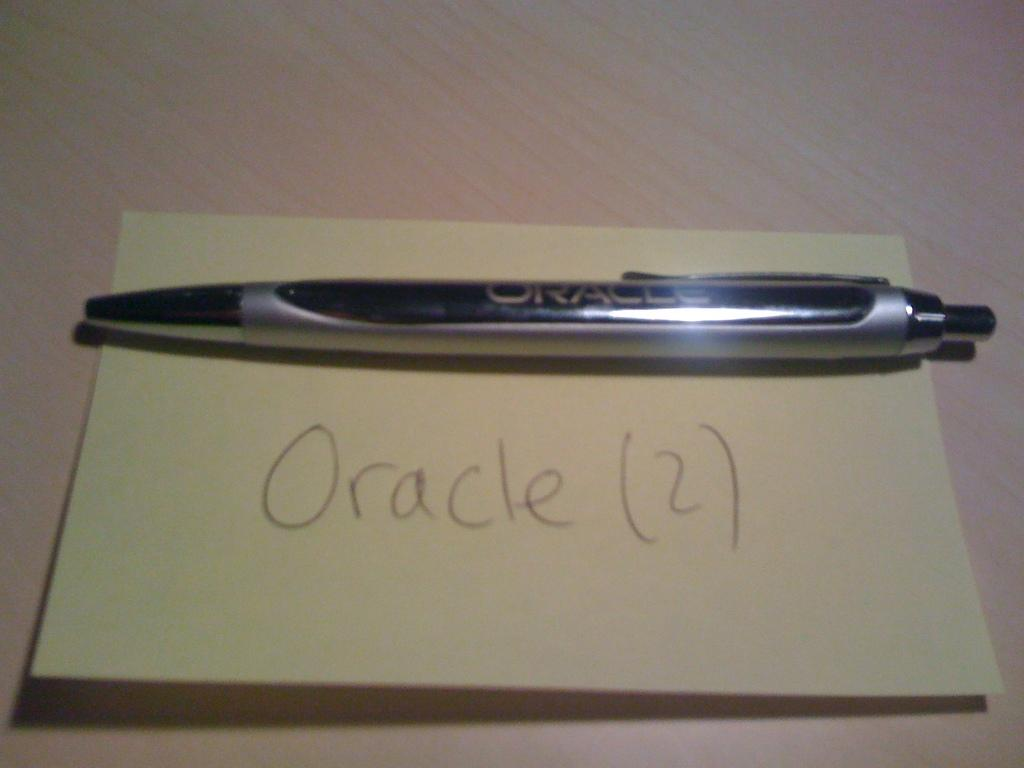What object is present in the image that is commonly used for writing? There is a pen in the image. Where is the pen located in the image? The pen is on a paper. What can be found on the paper that the pen is on? The paper contains written text. What type of clock is visible on the paper in the image? There is no clock present in the image; it only contains a pen and written text on a paper. 